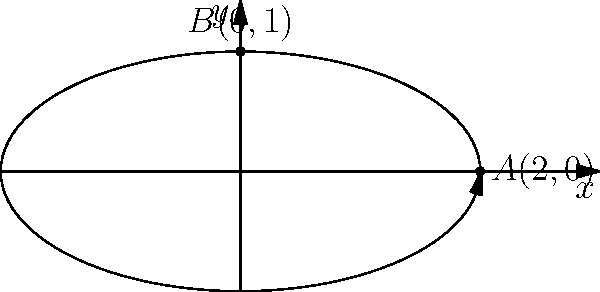A particle moves along the parametric curve defined by $x=2\cos t$ and $y=\sin t$. At what point on the curve is the rate of change of the particle's y-coordinate with respect to its x-coordinate equal to 1? To solve this problem, we need to follow these steps:

1) The rate of change of y with respect to x is given by $\frac{dy}{dx}$. We can find this using the chain rule:

   $\frac{dy}{dx} = \frac{dy/dt}{dx/dt}$

2) Let's calculate $\frac{dx}{dt}$ and $\frac{dy}{dt}$:
   
   $\frac{dx}{dt} = -2\sin t$
   $\frac{dy}{dt} = \cos t$

3) Now we can express $\frac{dy}{dx}$:

   $\frac{dy}{dx} = \frac{\cos t}{-2\sin t} = -\frac{\cos t}{2\sin t}$

4) We want this to equal 1:

   $-\frac{\cos t}{2\sin t} = 1$

5) Solving this equation:

   $\cos t = -2\sin t$
   $\cot t = -2$
   $t = \arctan(-\frac{1}{2}) + \pi = \frac{5\pi}{4}$

6) Now we can find the x and y coordinates at this t-value:

   $x = 2\cos(\frac{5\pi}{4}) = -\sqrt{2}$
   $y = \sin(\frac{5\pi}{4}) = -\frac{\sqrt{2}}{2}$

Therefore, the point is $(-\sqrt{2}, -\frac{\sqrt{2}}{2})$.
Answer: $(-\sqrt{2}, -\frac{\sqrt{2}}{2})$ 